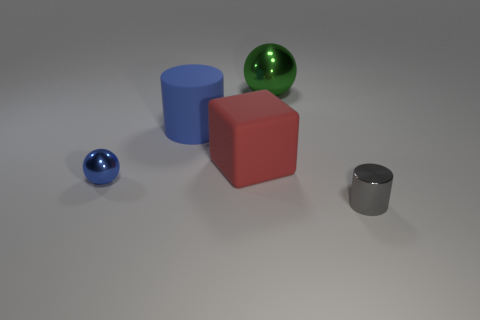Are there any other large green objects that have the same shape as the big green metallic thing?
Ensure brevity in your answer.  No. Is the material of the big thing in front of the big blue thing the same as the large object left of the large matte block?
Offer a terse response. Yes. There is a cylinder left of the small object right of the shiny ball right of the big cylinder; what is its size?
Ensure brevity in your answer.  Large. What is the material of the block that is the same size as the green object?
Your response must be concise. Rubber. Are there any purple rubber cylinders of the same size as the cube?
Your answer should be compact. No. Do the red thing and the big blue matte thing have the same shape?
Give a very brief answer. No. Is there a tiny cylinder on the left side of the tiny thing behind the small gray metal cylinder that is in front of the blue matte object?
Your answer should be compact. No. What number of other objects are the same color as the big sphere?
Offer a terse response. 0. Does the sphere on the left side of the red cube have the same size as the cylinder in front of the blue metallic ball?
Give a very brief answer. Yes. Are there an equal number of blue metal things that are on the right side of the gray metal thing and green metal objects in front of the blue rubber cylinder?
Your answer should be compact. Yes. 